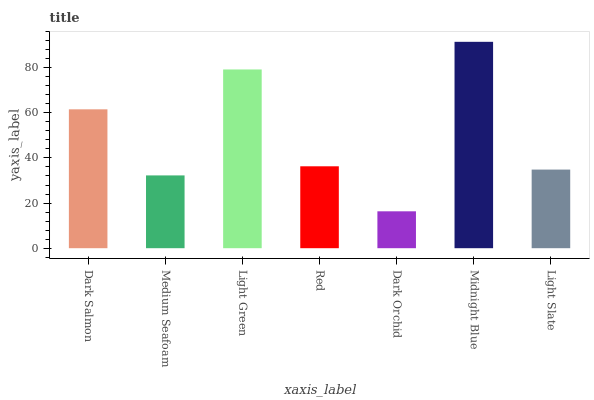Is Dark Orchid the minimum?
Answer yes or no. Yes. Is Midnight Blue the maximum?
Answer yes or no. Yes. Is Medium Seafoam the minimum?
Answer yes or no. No. Is Medium Seafoam the maximum?
Answer yes or no. No. Is Dark Salmon greater than Medium Seafoam?
Answer yes or no. Yes. Is Medium Seafoam less than Dark Salmon?
Answer yes or no. Yes. Is Medium Seafoam greater than Dark Salmon?
Answer yes or no. No. Is Dark Salmon less than Medium Seafoam?
Answer yes or no. No. Is Red the high median?
Answer yes or no. Yes. Is Red the low median?
Answer yes or no. Yes. Is Dark Salmon the high median?
Answer yes or no. No. Is Dark Salmon the low median?
Answer yes or no. No. 